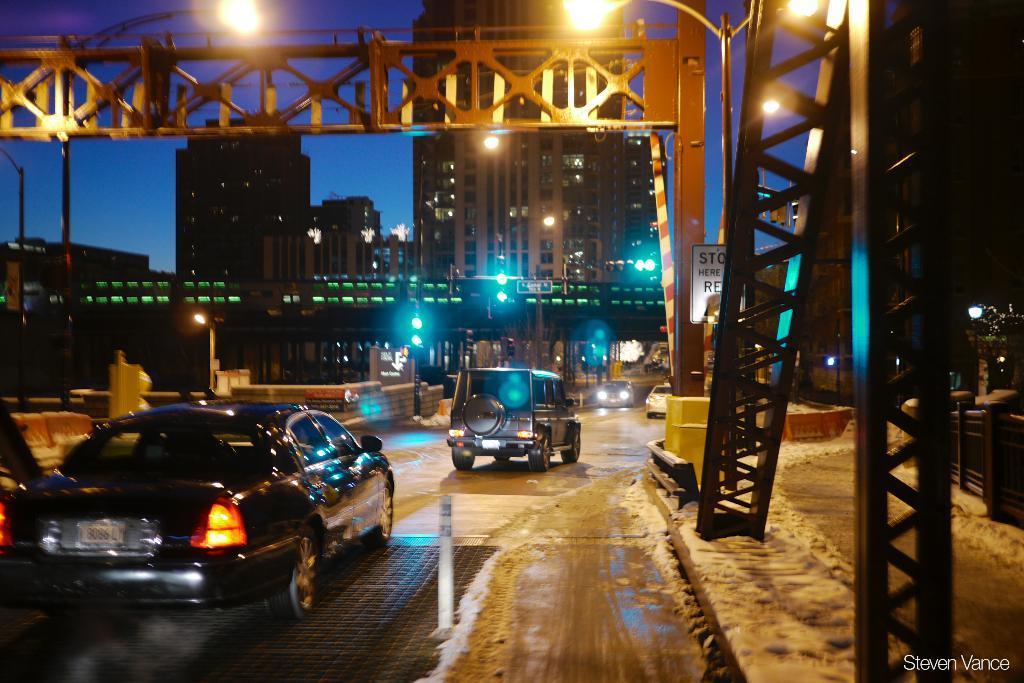Describe this image in one or two sentences. In this image there is the sky, there are buildings, there is a building truncated towards the top of the image, there are poles, there are street lights truncated towards the top of the image, there is the wall, there is road, there are vehicles on the road, there are boards, there is text on the boards, there are objects truncated towards the right of the image, there is text towards the bottom of the image, there is a vehicle truncated towards the left of the image, there is a building truncated towards the left of the image. 